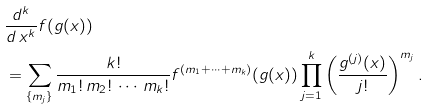Convert formula to latex. <formula><loc_0><loc_0><loc_500><loc_500>& \frac { d ^ { k } } { d \, x ^ { k } } f ( g ( x ) ) \\ & = \sum _ { \{ m _ { j } \} } \frac { k ! } { m _ { 1 } ! \, m _ { 2 } ! \, \cdots \, m _ { k } ! } f ^ { ( m _ { 1 } + \cdots + m _ { k } ) } ( g ( x ) ) \prod _ { j = 1 } ^ { k } \left ( \frac { g ^ { ( j ) } ( x ) } { j ! } \right ) ^ { m _ { j } } .</formula> 